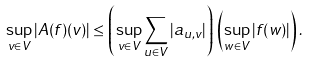<formula> <loc_0><loc_0><loc_500><loc_500>\sup _ { v \in V } | A ( f ) ( v ) | \leq \left ( \sup _ { v \in V } \sum _ { u \in V } | a _ { u , v } | \right ) \, \left ( \sup _ { w \in V } | f ( w ) | \right ) .</formula> 